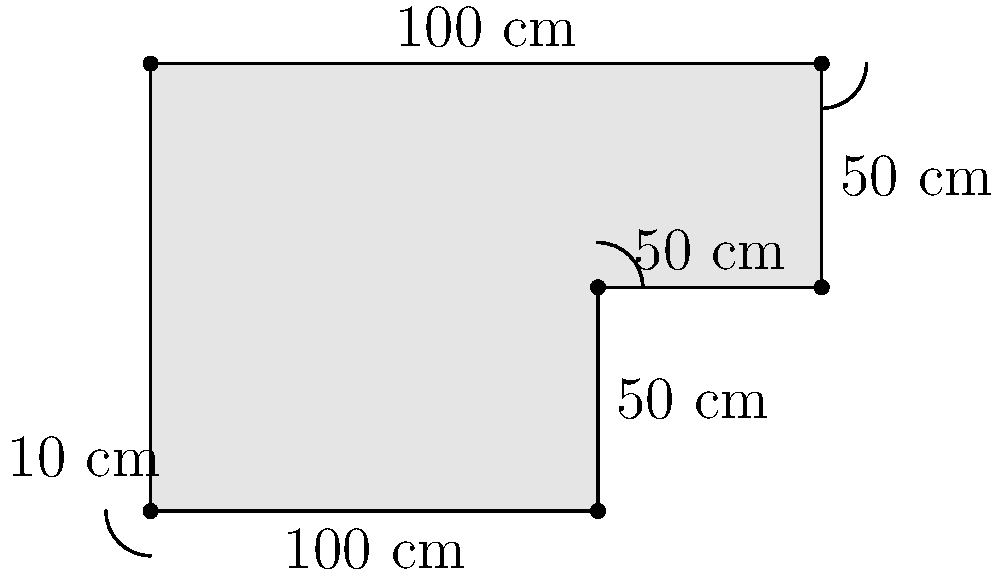You're designing a custom L-shaped kitchen island for your new home. The island has rounded corners with a radius of 10 cm each. Given the dimensions shown in the diagram, calculate the perimeter of the island. To find the perimeter, we need to:
1. Calculate the total length of straight edges
2. Calculate the length of the rounded corners
3. Subtract the overlapping parts
4. Add the results

Step 1: Total length of straight edges
$$(100 + 50 + 50 + 50 + 100) \text{ cm} = 350 \text{ cm}$$

Step 2: Length of rounded corners
There are 3 rounded corners, each a quarter circle with radius 10 cm.
Length of one quarter circle = $\frac{1}{4} \times 2\pi r = \frac{1}{2}\pi r$
Total length of rounded corners = $3 \times \frac{1}{2}\pi \times 10 = 15\pi \text{ cm}$

Step 3: Overlapping parts
For each rounded corner, we need to subtract twice the radius:
$3 \times (2 \times 10) \text{ cm} = 60 \text{ cm}$

Step 4: Add the results
Total perimeter = Straight edges + Rounded corners - Overlapping parts
$$350 + 15\pi - 60 = 290 + 15\pi \text{ cm}$$

Approximating $\pi$ to 3.14159:
$$(290 + 15 \times 3.14159) \text{ cm} \approx 337.12 \text{ cm}$$
Answer: $290 + 15\pi \text{ cm}$ (or approximately 337.12 cm) 